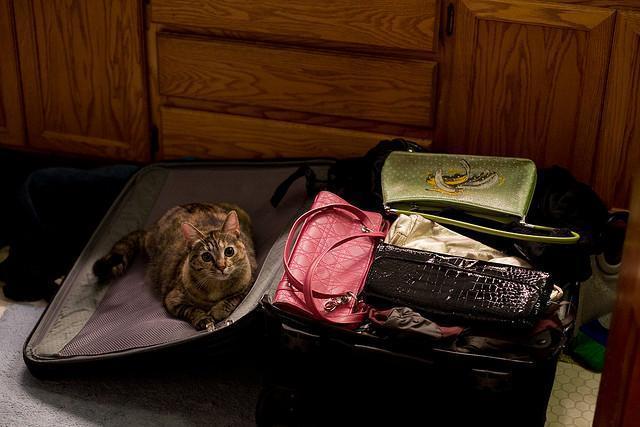How many handbags can be seen?
Give a very brief answer. 3. 